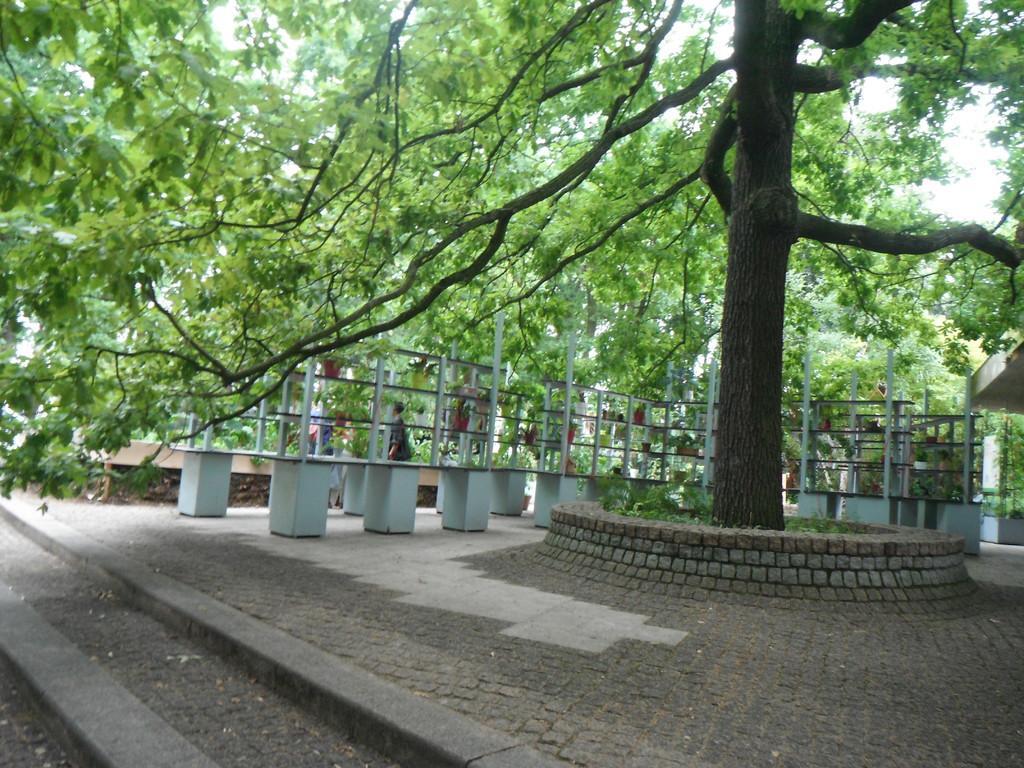Could you give a brief overview of what you see in this image? In this image we can see a tree. Beside the tree we can see few plants and a wall. Behind the tree we can see the poles, persons and a group of trees. At the top we can see the sky. On the right side, we can see a roof. 